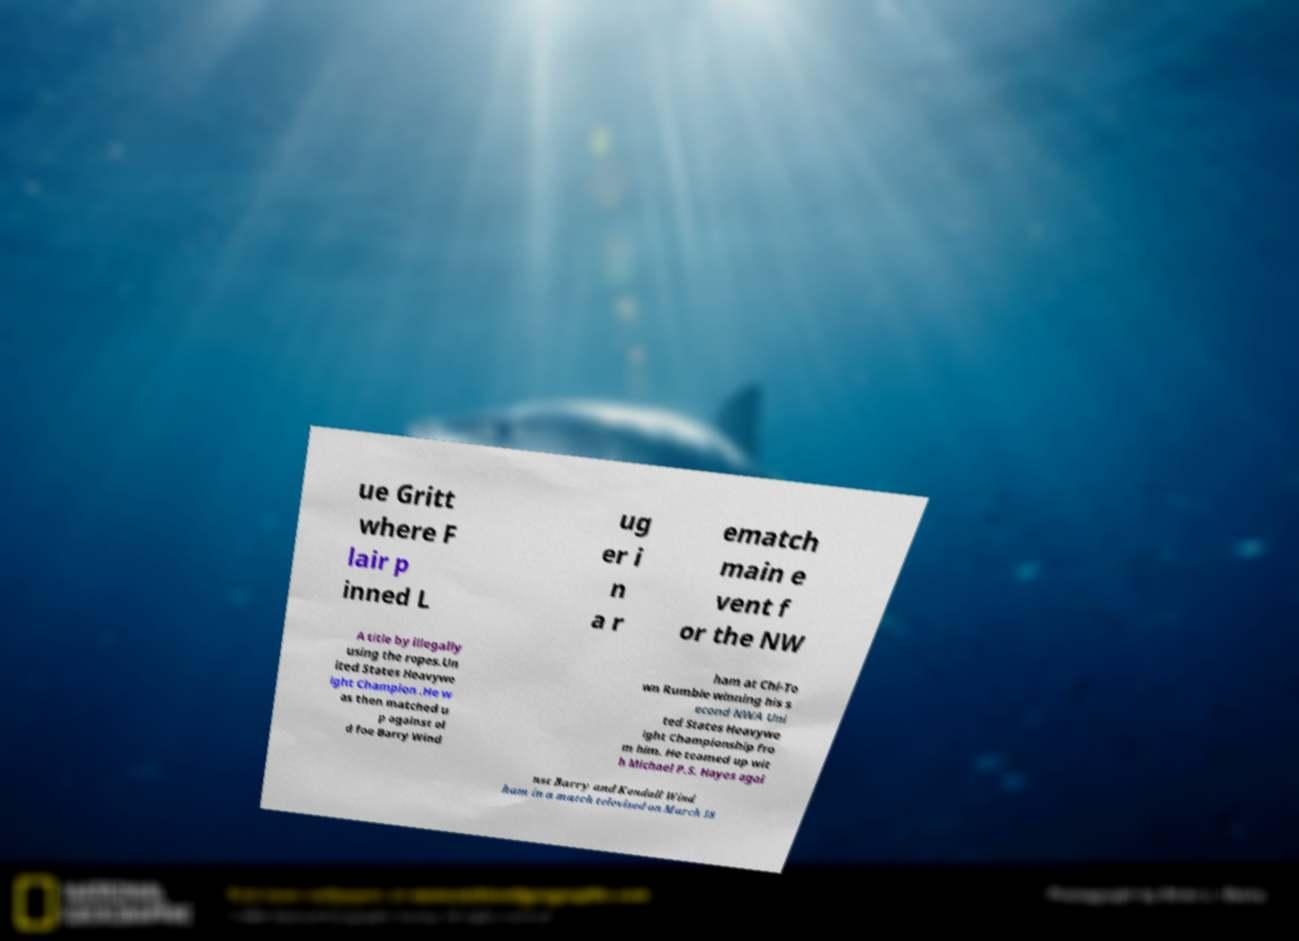For documentation purposes, I need the text within this image transcribed. Could you provide that? ue Gritt where F lair p inned L ug er i n a r ematch main e vent f or the NW A title by illegally using the ropes.Un ited States Heavywe ight Champion .He w as then matched u p against ol d foe Barry Wind ham at Chi-To wn Rumble winning his s econd NWA Uni ted States Heavywe ight Championship fro m him. He teamed up wit h Michael P.S. Hayes agai nst Barry and Kendall Wind ham in a match televised on March 18 